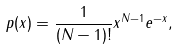Convert formula to latex. <formula><loc_0><loc_0><loc_500><loc_500>p ( x ) = \frac { 1 } { ( N - 1 ) ! } x ^ { N - 1 } e ^ { - x } ,</formula> 